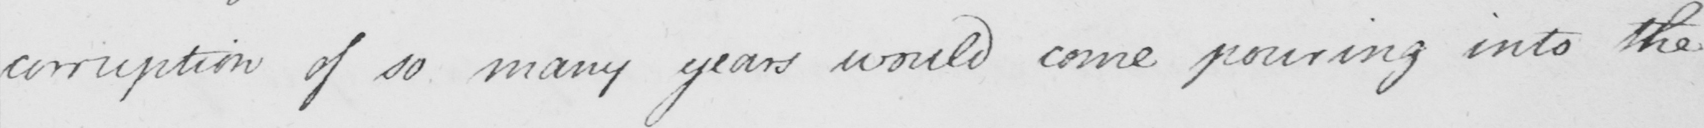Can you read and transcribe this handwriting? corruption of so many years would come pouring into the 